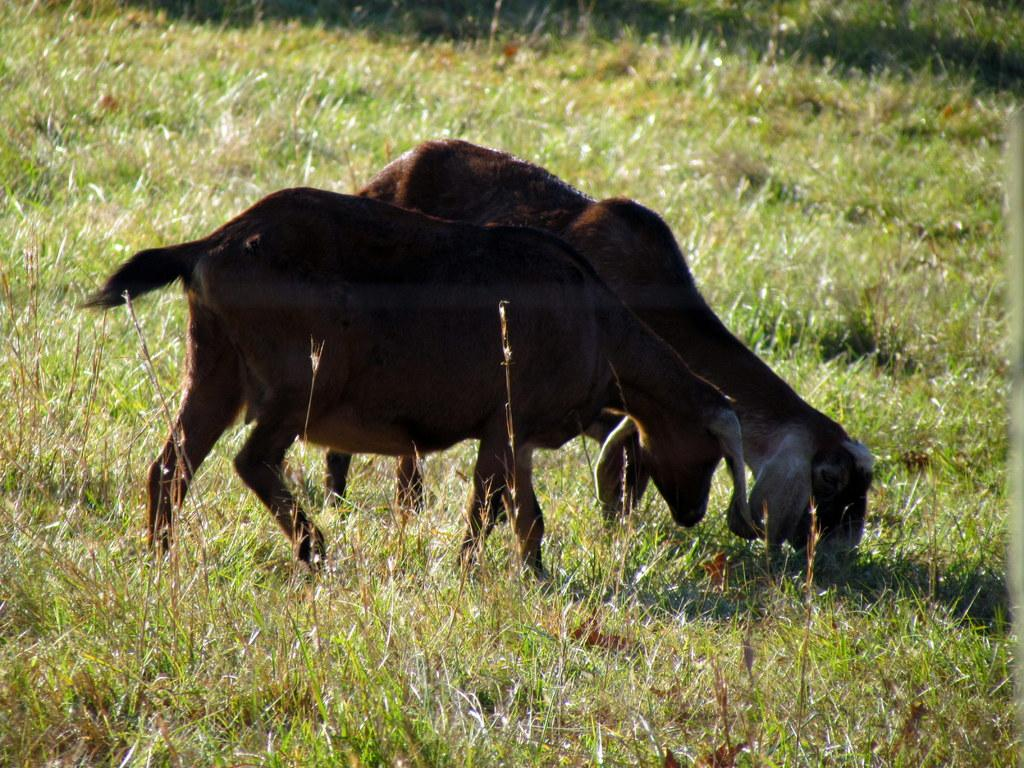How many animals are present in the image? There are two animals in the image. Where are the animals located in the image? The animals are on a grass path. What type of band is playing music in the background of the image? There is no band present in the image, and therefore no music can be heard. 